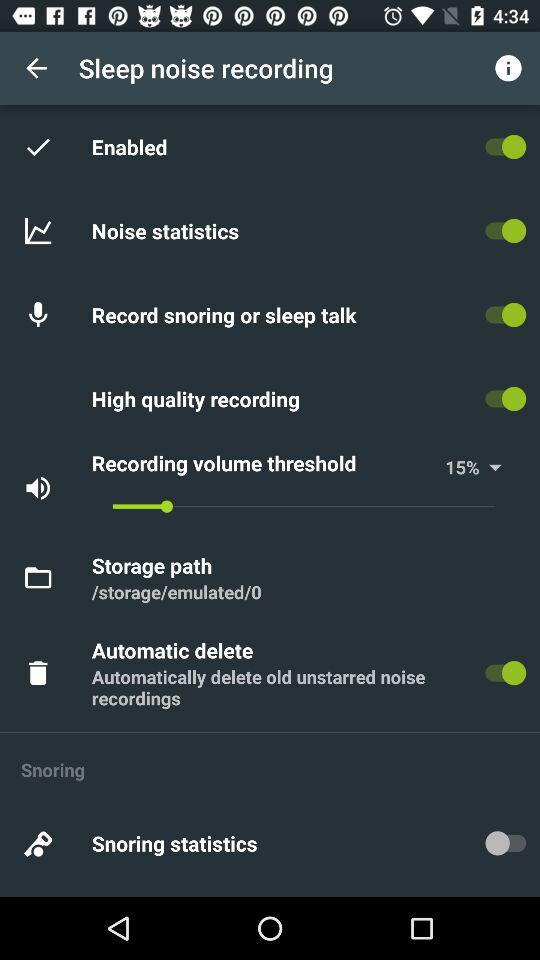What is the status of "Enabled"? The status of "Enabled" is "on". 